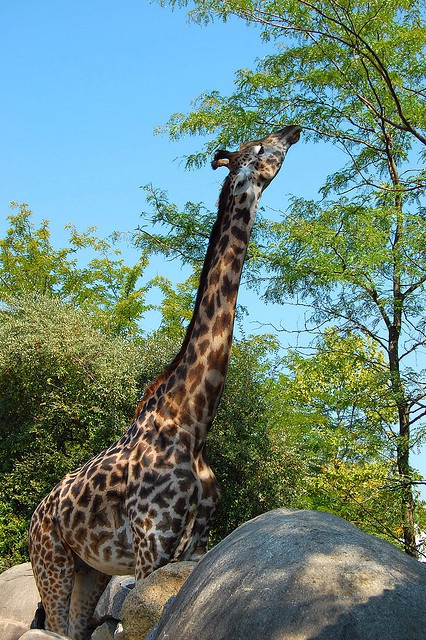Describe the objects in this image and their specific colors. I can see a giraffe in lightblue, black, gray, and maroon tones in this image. 